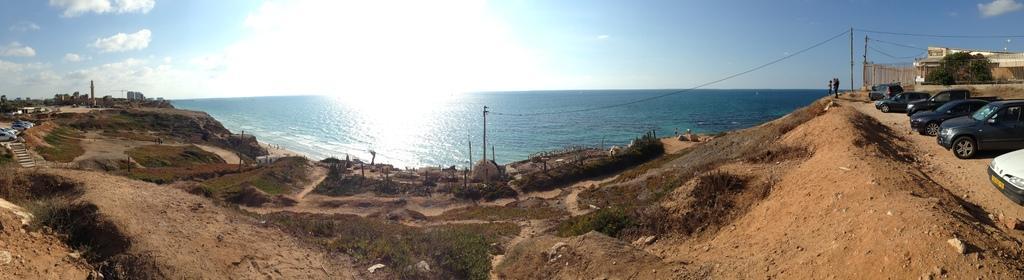Could you give a brief overview of what you see in this image? In this picture there are vehicles and there are buildings and trees. On the right side of the image there are two persons standing and there are poles and there are wires on the poles. At the top there is sky and there are clouds and there is a sunshine. At the bottom there is ground and there is grass. At the back there is water. 